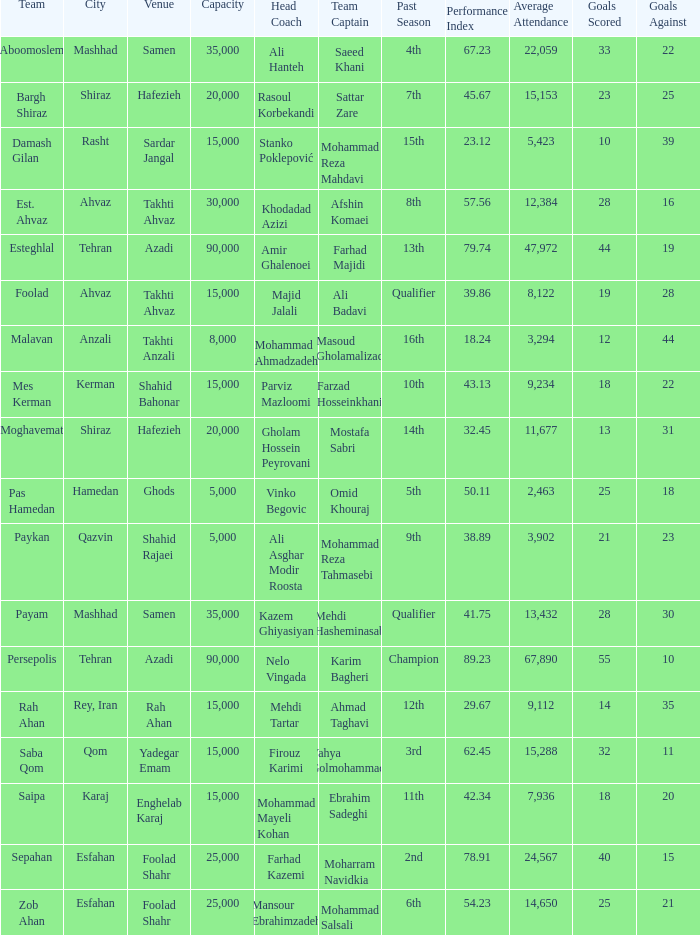Could you parse the entire table as a dict? {'header': ['Team', 'City', 'Venue', 'Capacity', 'Head Coach', 'Team Captain', 'Past Season', 'Performance Index', 'Average Attendance', 'Goals Scored', 'Goals Against'], 'rows': [['Aboomoslem', 'Mashhad', 'Samen', '35,000', 'Ali Hanteh', 'Saeed Khani', '4th', '67.23', '22,059', '33', '22'], ['Bargh Shiraz', 'Shiraz', 'Hafezieh', '20,000', 'Rasoul Korbekandi', 'Sattar Zare', '7th', '45.67', '15,153', '23', '25'], ['Damash Gilan', 'Rasht', 'Sardar Jangal', '15,000', 'Stanko Poklepović', 'Mohammad Reza Mahdavi', '15th', '23.12', '5,423', '10', '39'], ['Est. Ahvaz', 'Ahvaz', 'Takhti Ahvaz', '30,000', 'Khodadad Azizi', 'Afshin Komaei', '8th', '57.56', '12,384', '28', '16'], ['Esteghlal', 'Tehran', 'Azadi', '90,000', 'Amir Ghalenoei', 'Farhad Majidi', '13th', '79.74', '47,972', '44', '19'], ['Foolad', 'Ahvaz', 'Takhti Ahvaz', '15,000', 'Majid Jalali', 'Ali Badavi', 'Qualifier', '39.86', '8,122', '19', '28'], ['Malavan', 'Anzali', 'Takhti Anzali', '8,000', 'Mohammad Ahmadzadeh', 'Masoud Gholamalizad', '16th', '18.24', '3,294', '12', '44'], ['Mes Kerman', 'Kerman', 'Shahid Bahonar', '15,000', 'Parviz Mazloomi', 'Farzad Hosseinkhani', '10th', '43.13', '9,234', '18', '22'], ['Moghavemat', 'Shiraz', 'Hafezieh', '20,000', 'Gholam Hossein Peyrovani', 'Mostafa Sabri', '14th', '32.45', '11,677', '13', '31'], ['Pas Hamedan', 'Hamedan', 'Ghods', '5,000', 'Vinko Begovic', 'Omid Khouraj', '5th', '50.11', '2,463', '25', '18'], ['Paykan', 'Qazvin', 'Shahid Rajaei', '5,000', 'Ali Asghar Modir Roosta', 'Mohammad Reza Tahmasebi', '9th', '38.89', '3,902', '21', '23'], ['Payam', 'Mashhad', 'Samen', '35,000', 'Kazem Ghiyasiyan', 'Mehdi Hasheminasab', 'Qualifier', '41.75', '13,432', '28', '30'], ['Persepolis', 'Tehran', 'Azadi', '90,000', 'Nelo Vingada', 'Karim Bagheri', 'Champion', '89.23', '67,890', '55', '10'], ['Rah Ahan', 'Rey, Iran', 'Rah Ahan', '15,000', 'Mehdi Tartar', 'Ahmad Taghavi', '12th', '29.67', '9,112', '14', '35'], ['Saba Qom', 'Qom', 'Yadegar Emam', '15,000', 'Firouz Karimi', 'Yahya Golmohammadi', '3rd', '62.45', '15,288', '32', '11'], ['Saipa', 'Karaj', 'Enghelab Karaj', '15,000', 'Mohammad Mayeli Kohan', 'Ebrahim Sadeghi', '11th', '42.34', '7,936', '18', '20'], ['Sepahan', 'Esfahan', 'Foolad Shahr', '25,000', 'Farhad Kazemi', 'Moharram Navidkia', '2nd', '78.91', '24,567', '40', '15'], ['Zob Ahan', 'Esfahan', 'Foolad Shahr', '25,000', 'Mansour Ebrahimzadeh', 'Mohammad Salsali', '6th', '54.23', '14,650', '25', '21']]} What Venue has a Past Season of 2nd? Foolad Shahr. 